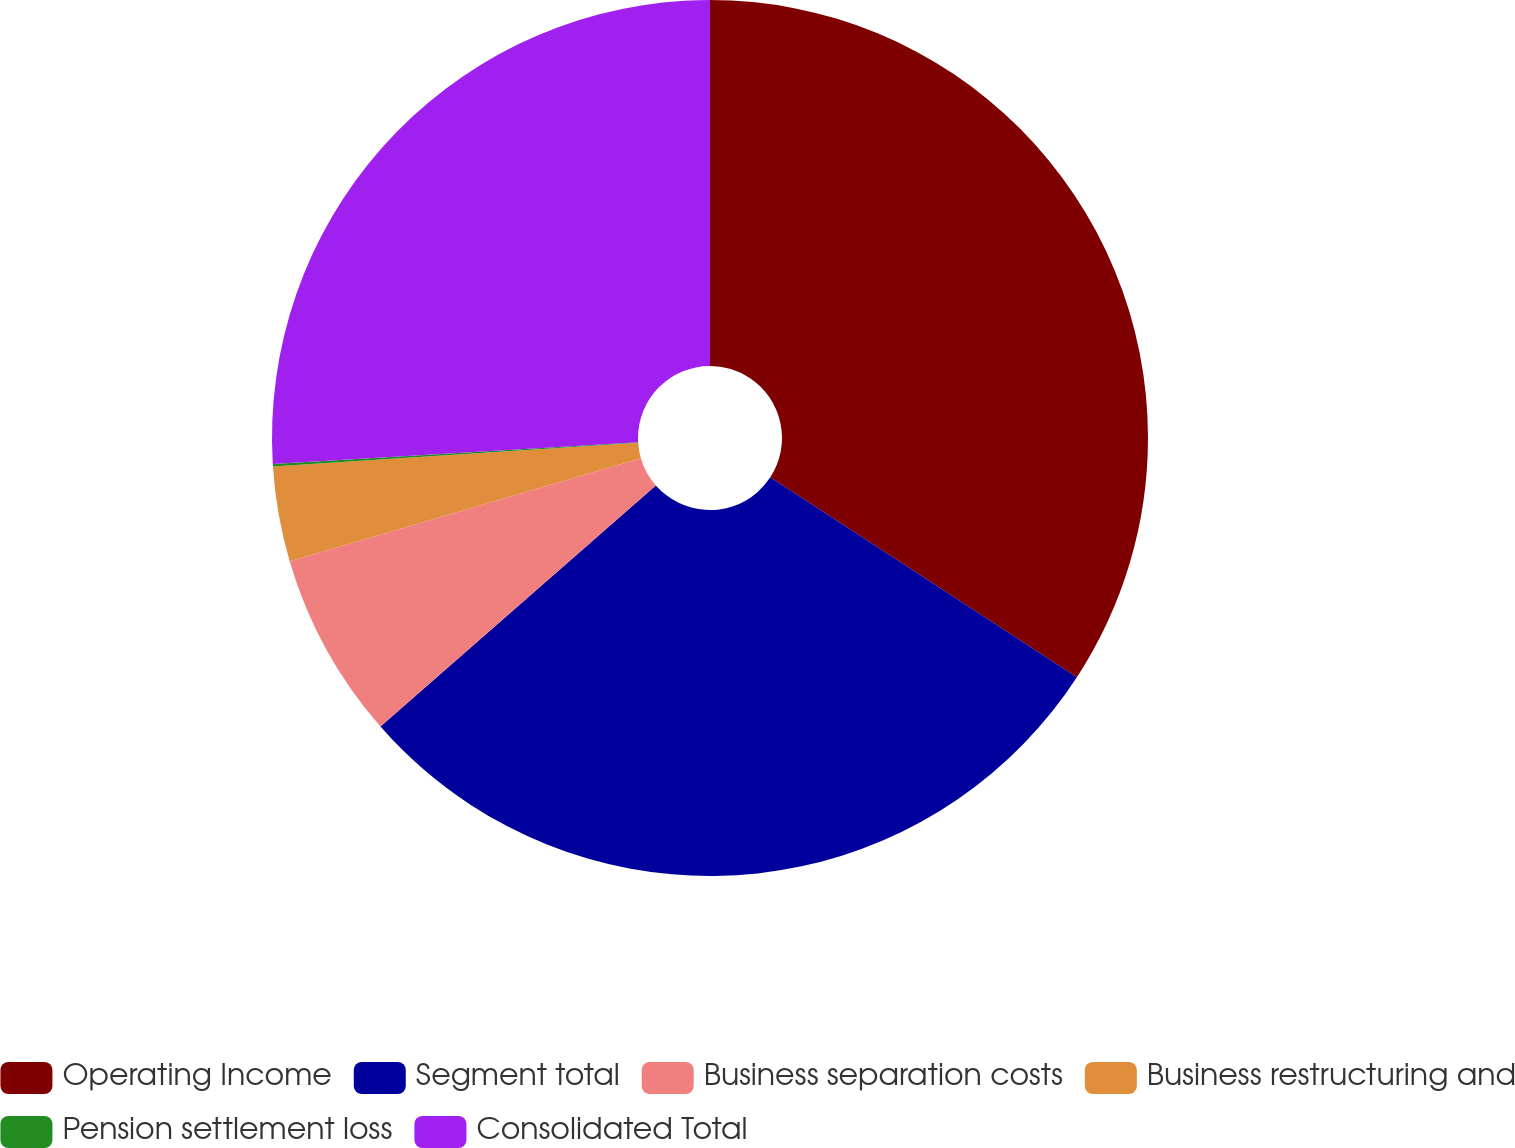Convert chart. <chart><loc_0><loc_0><loc_500><loc_500><pie_chart><fcel>Operating Income<fcel>Segment total<fcel>Business separation costs<fcel>Business restructuring and<fcel>Pension settlement loss<fcel>Consolidated Total<nl><fcel>34.2%<fcel>29.36%<fcel>6.91%<fcel>3.5%<fcel>0.09%<fcel>25.95%<nl></chart> 